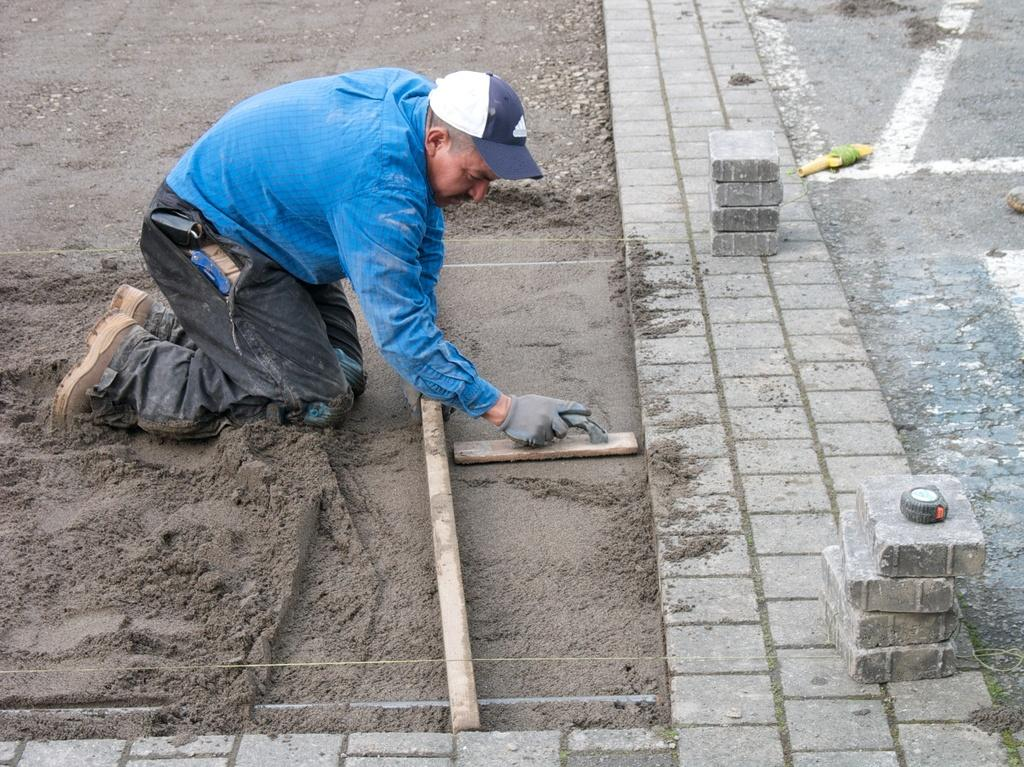What is present in the image? There is a person in the image. What is the person doing in the image? The person is doing concrete work. What is the person holding in the image? The person is holding an object. What type of quartz can be seen in the image? There is no quartz present in the image. Can you tell me how the person became an expert in concrete work? The image does not provide information about the person's expertise or how they acquired their skills. 